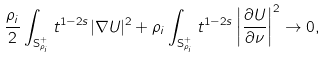Convert formula to latex. <formula><loc_0><loc_0><loc_500><loc_500>\frac { \rho _ { i } } { 2 } \int _ { \mathbf S _ { \rho _ { i } } ^ { + } } t ^ { 1 - 2 s } | \nabla U | ^ { 2 } + \rho _ { i } \int _ { \mathbf S _ { \rho _ { i } } ^ { + } } t ^ { 1 - 2 s } \left | \frac { \partial U } { \partial \nu } \right | ^ { 2 } \to 0 ,</formula> 